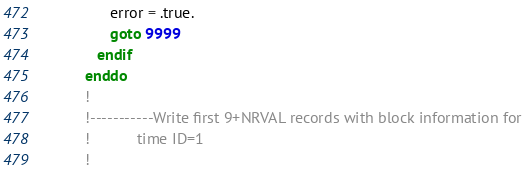<code> <loc_0><loc_0><loc_500><loc_500><_FORTRAN_>                error = .true.
                goto 9999
             endif
          enddo
          !
          !-----------Write first 9+NRVAL records with block information for
          !           time ID=1
          !</code> 